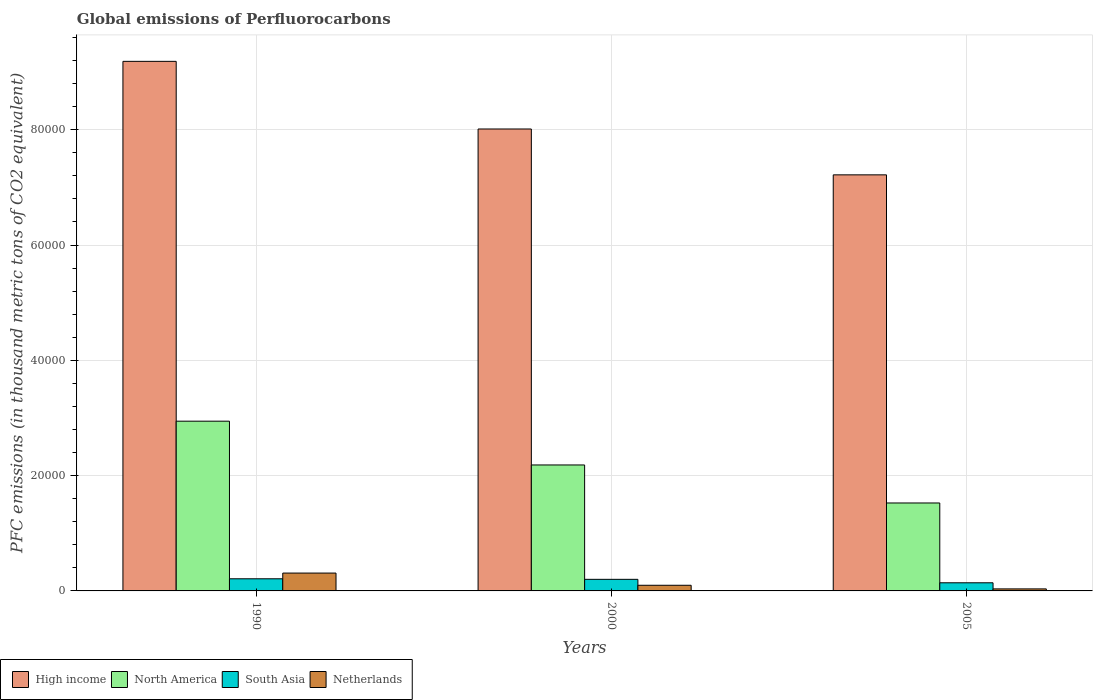How many different coloured bars are there?
Your response must be concise. 4. How many groups of bars are there?
Make the answer very short. 3. Are the number of bars per tick equal to the number of legend labels?
Keep it short and to the point. Yes. Are the number of bars on each tick of the X-axis equal?
Your answer should be compact. Yes. How many bars are there on the 3rd tick from the right?
Offer a very short reply. 4. In how many cases, is the number of bars for a given year not equal to the number of legend labels?
Keep it short and to the point. 0. What is the global emissions of Perfluorocarbons in Netherlands in 2000?
Your answer should be very brief. 979.5. Across all years, what is the maximum global emissions of Perfluorocarbons in High income?
Your answer should be compact. 9.19e+04. Across all years, what is the minimum global emissions of Perfluorocarbons in Netherlands?
Provide a short and direct response. 351.4. In which year was the global emissions of Perfluorocarbons in North America minimum?
Make the answer very short. 2005. What is the total global emissions of Perfluorocarbons in North America in the graph?
Keep it short and to the point. 6.65e+04. What is the difference between the global emissions of Perfluorocarbons in Netherlands in 2000 and that in 2005?
Keep it short and to the point. 628.1. What is the difference between the global emissions of Perfluorocarbons in Netherlands in 2000 and the global emissions of Perfluorocarbons in North America in 2005?
Provide a short and direct response. -1.43e+04. What is the average global emissions of Perfluorocarbons in South Asia per year?
Your answer should be very brief. 1841.21. In the year 2005, what is the difference between the global emissions of Perfluorocarbons in Netherlands and global emissions of Perfluorocarbons in North America?
Provide a succinct answer. -1.49e+04. What is the ratio of the global emissions of Perfluorocarbons in High income in 1990 to that in 2005?
Give a very brief answer. 1.27. Is the difference between the global emissions of Perfluorocarbons in Netherlands in 1990 and 2005 greater than the difference between the global emissions of Perfluorocarbons in North America in 1990 and 2005?
Keep it short and to the point. No. What is the difference between the highest and the second highest global emissions of Perfluorocarbons in South Asia?
Provide a short and direct response. 95.2. What is the difference between the highest and the lowest global emissions of Perfluorocarbons in High income?
Offer a terse response. 1.97e+04. Is the sum of the global emissions of Perfluorocarbons in Netherlands in 2000 and 2005 greater than the maximum global emissions of Perfluorocarbons in North America across all years?
Your response must be concise. No. Is it the case that in every year, the sum of the global emissions of Perfluorocarbons in Netherlands and global emissions of Perfluorocarbons in High income is greater than the sum of global emissions of Perfluorocarbons in North America and global emissions of Perfluorocarbons in South Asia?
Your response must be concise. Yes. What does the 4th bar from the right in 2005 represents?
Ensure brevity in your answer.  High income. Is it the case that in every year, the sum of the global emissions of Perfluorocarbons in Netherlands and global emissions of Perfluorocarbons in South Asia is greater than the global emissions of Perfluorocarbons in High income?
Your answer should be very brief. No. How many bars are there?
Provide a succinct answer. 12. Are all the bars in the graph horizontal?
Your response must be concise. No. What is the difference between two consecutive major ticks on the Y-axis?
Ensure brevity in your answer.  2.00e+04. Does the graph contain grids?
Provide a succinct answer. Yes. Where does the legend appear in the graph?
Make the answer very short. Bottom left. How many legend labels are there?
Offer a terse response. 4. What is the title of the graph?
Offer a very short reply. Global emissions of Perfluorocarbons. What is the label or title of the Y-axis?
Make the answer very short. PFC emissions (in thousand metric tons of CO2 equivalent). What is the PFC emissions (in thousand metric tons of CO2 equivalent) of High income in 1990?
Offer a very short reply. 9.19e+04. What is the PFC emissions (in thousand metric tons of CO2 equivalent) of North America in 1990?
Your response must be concise. 2.94e+04. What is the PFC emissions (in thousand metric tons of CO2 equivalent) in South Asia in 1990?
Provide a short and direct response. 2104. What is the PFC emissions (in thousand metric tons of CO2 equivalent) of Netherlands in 1990?
Your answer should be compact. 3096.2. What is the PFC emissions (in thousand metric tons of CO2 equivalent) in High income in 2000?
Your answer should be compact. 8.01e+04. What is the PFC emissions (in thousand metric tons of CO2 equivalent) in North America in 2000?
Provide a succinct answer. 2.18e+04. What is the PFC emissions (in thousand metric tons of CO2 equivalent) of South Asia in 2000?
Keep it short and to the point. 2008.8. What is the PFC emissions (in thousand metric tons of CO2 equivalent) of Netherlands in 2000?
Your answer should be very brief. 979.5. What is the PFC emissions (in thousand metric tons of CO2 equivalent) of High income in 2005?
Make the answer very short. 7.22e+04. What is the PFC emissions (in thousand metric tons of CO2 equivalent) of North America in 2005?
Your answer should be compact. 1.53e+04. What is the PFC emissions (in thousand metric tons of CO2 equivalent) of South Asia in 2005?
Offer a very short reply. 1410.84. What is the PFC emissions (in thousand metric tons of CO2 equivalent) of Netherlands in 2005?
Offer a very short reply. 351.4. Across all years, what is the maximum PFC emissions (in thousand metric tons of CO2 equivalent) of High income?
Provide a succinct answer. 9.19e+04. Across all years, what is the maximum PFC emissions (in thousand metric tons of CO2 equivalent) in North America?
Give a very brief answer. 2.94e+04. Across all years, what is the maximum PFC emissions (in thousand metric tons of CO2 equivalent) in South Asia?
Your answer should be very brief. 2104. Across all years, what is the maximum PFC emissions (in thousand metric tons of CO2 equivalent) of Netherlands?
Your answer should be very brief. 3096.2. Across all years, what is the minimum PFC emissions (in thousand metric tons of CO2 equivalent) in High income?
Make the answer very short. 7.22e+04. Across all years, what is the minimum PFC emissions (in thousand metric tons of CO2 equivalent) in North America?
Your answer should be compact. 1.53e+04. Across all years, what is the minimum PFC emissions (in thousand metric tons of CO2 equivalent) in South Asia?
Give a very brief answer. 1410.84. Across all years, what is the minimum PFC emissions (in thousand metric tons of CO2 equivalent) of Netherlands?
Offer a very short reply. 351.4. What is the total PFC emissions (in thousand metric tons of CO2 equivalent) in High income in the graph?
Your answer should be very brief. 2.44e+05. What is the total PFC emissions (in thousand metric tons of CO2 equivalent) of North America in the graph?
Provide a short and direct response. 6.65e+04. What is the total PFC emissions (in thousand metric tons of CO2 equivalent) of South Asia in the graph?
Your response must be concise. 5523.64. What is the total PFC emissions (in thousand metric tons of CO2 equivalent) of Netherlands in the graph?
Make the answer very short. 4427.1. What is the difference between the PFC emissions (in thousand metric tons of CO2 equivalent) in High income in 1990 and that in 2000?
Provide a short and direct response. 1.17e+04. What is the difference between the PFC emissions (in thousand metric tons of CO2 equivalent) in North America in 1990 and that in 2000?
Offer a terse response. 7592.7. What is the difference between the PFC emissions (in thousand metric tons of CO2 equivalent) of South Asia in 1990 and that in 2000?
Your response must be concise. 95.2. What is the difference between the PFC emissions (in thousand metric tons of CO2 equivalent) in Netherlands in 1990 and that in 2000?
Offer a very short reply. 2116.7. What is the difference between the PFC emissions (in thousand metric tons of CO2 equivalent) in High income in 1990 and that in 2005?
Provide a succinct answer. 1.97e+04. What is the difference between the PFC emissions (in thousand metric tons of CO2 equivalent) of North America in 1990 and that in 2005?
Your answer should be compact. 1.42e+04. What is the difference between the PFC emissions (in thousand metric tons of CO2 equivalent) of South Asia in 1990 and that in 2005?
Your response must be concise. 693.16. What is the difference between the PFC emissions (in thousand metric tons of CO2 equivalent) of Netherlands in 1990 and that in 2005?
Your answer should be compact. 2744.8. What is the difference between the PFC emissions (in thousand metric tons of CO2 equivalent) in High income in 2000 and that in 2005?
Make the answer very short. 7954.84. What is the difference between the PFC emissions (in thousand metric tons of CO2 equivalent) in North America in 2000 and that in 2005?
Offer a terse response. 6595.81. What is the difference between the PFC emissions (in thousand metric tons of CO2 equivalent) in South Asia in 2000 and that in 2005?
Your answer should be compact. 597.96. What is the difference between the PFC emissions (in thousand metric tons of CO2 equivalent) of Netherlands in 2000 and that in 2005?
Your answer should be very brief. 628.1. What is the difference between the PFC emissions (in thousand metric tons of CO2 equivalent) in High income in 1990 and the PFC emissions (in thousand metric tons of CO2 equivalent) in North America in 2000?
Offer a very short reply. 7.00e+04. What is the difference between the PFC emissions (in thousand metric tons of CO2 equivalent) in High income in 1990 and the PFC emissions (in thousand metric tons of CO2 equivalent) in South Asia in 2000?
Offer a terse response. 8.98e+04. What is the difference between the PFC emissions (in thousand metric tons of CO2 equivalent) in High income in 1990 and the PFC emissions (in thousand metric tons of CO2 equivalent) in Netherlands in 2000?
Keep it short and to the point. 9.09e+04. What is the difference between the PFC emissions (in thousand metric tons of CO2 equivalent) in North America in 1990 and the PFC emissions (in thousand metric tons of CO2 equivalent) in South Asia in 2000?
Offer a very short reply. 2.74e+04. What is the difference between the PFC emissions (in thousand metric tons of CO2 equivalent) in North America in 1990 and the PFC emissions (in thousand metric tons of CO2 equivalent) in Netherlands in 2000?
Keep it short and to the point. 2.85e+04. What is the difference between the PFC emissions (in thousand metric tons of CO2 equivalent) of South Asia in 1990 and the PFC emissions (in thousand metric tons of CO2 equivalent) of Netherlands in 2000?
Provide a short and direct response. 1124.5. What is the difference between the PFC emissions (in thousand metric tons of CO2 equivalent) in High income in 1990 and the PFC emissions (in thousand metric tons of CO2 equivalent) in North America in 2005?
Your answer should be very brief. 7.66e+04. What is the difference between the PFC emissions (in thousand metric tons of CO2 equivalent) of High income in 1990 and the PFC emissions (in thousand metric tons of CO2 equivalent) of South Asia in 2005?
Your answer should be very brief. 9.04e+04. What is the difference between the PFC emissions (in thousand metric tons of CO2 equivalent) in High income in 1990 and the PFC emissions (in thousand metric tons of CO2 equivalent) in Netherlands in 2005?
Give a very brief answer. 9.15e+04. What is the difference between the PFC emissions (in thousand metric tons of CO2 equivalent) in North America in 1990 and the PFC emissions (in thousand metric tons of CO2 equivalent) in South Asia in 2005?
Provide a short and direct response. 2.80e+04. What is the difference between the PFC emissions (in thousand metric tons of CO2 equivalent) in North America in 1990 and the PFC emissions (in thousand metric tons of CO2 equivalent) in Netherlands in 2005?
Offer a terse response. 2.91e+04. What is the difference between the PFC emissions (in thousand metric tons of CO2 equivalent) of South Asia in 1990 and the PFC emissions (in thousand metric tons of CO2 equivalent) of Netherlands in 2005?
Offer a terse response. 1752.6. What is the difference between the PFC emissions (in thousand metric tons of CO2 equivalent) in High income in 2000 and the PFC emissions (in thousand metric tons of CO2 equivalent) in North America in 2005?
Offer a very short reply. 6.49e+04. What is the difference between the PFC emissions (in thousand metric tons of CO2 equivalent) in High income in 2000 and the PFC emissions (in thousand metric tons of CO2 equivalent) in South Asia in 2005?
Your response must be concise. 7.87e+04. What is the difference between the PFC emissions (in thousand metric tons of CO2 equivalent) in High income in 2000 and the PFC emissions (in thousand metric tons of CO2 equivalent) in Netherlands in 2005?
Offer a terse response. 7.98e+04. What is the difference between the PFC emissions (in thousand metric tons of CO2 equivalent) of North America in 2000 and the PFC emissions (in thousand metric tons of CO2 equivalent) of South Asia in 2005?
Your answer should be compact. 2.04e+04. What is the difference between the PFC emissions (in thousand metric tons of CO2 equivalent) of North America in 2000 and the PFC emissions (in thousand metric tons of CO2 equivalent) of Netherlands in 2005?
Your response must be concise. 2.15e+04. What is the difference between the PFC emissions (in thousand metric tons of CO2 equivalent) of South Asia in 2000 and the PFC emissions (in thousand metric tons of CO2 equivalent) of Netherlands in 2005?
Your answer should be very brief. 1657.4. What is the average PFC emissions (in thousand metric tons of CO2 equivalent) in High income per year?
Provide a succinct answer. 8.14e+04. What is the average PFC emissions (in thousand metric tons of CO2 equivalent) of North America per year?
Ensure brevity in your answer.  2.22e+04. What is the average PFC emissions (in thousand metric tons of CO2 equivalent) of South Asia per year?
Provide a short and direct response. 1841.21. What is the average PFC emissions (in thousand metric tons of CO2 equivalent) in Netherlands per year?
Offer a terse response. 1475.7. In the year 1990, what is the difference between the PFC emissions (in thousand metric tons of CO2 equivalent) of High income and PFC emissions (in thousand metric tons of CO2 equivalent) of North America?
Provide a succinct answer. 6.24e+04. In the year 1990, what is the difference between the PFC emissions (in thousand metric tons of CO2 equivalent) of High income and PFC emissions (in thousand metric tons of CO2 equivalent) of South Asia?
Make the answer very short. 8.98e+04. In the year 1990, what is the difference between the PFC emissions (in thousand metric tons of CO2 equivalent) of High income and PFC emissions (in thousand metric tons of CO2 equivalent) of Netherlands?
Make the answer very short. 8.88e+04. In the year 1990, what is the difference between the PFC emissions (in thousand metric tons of CO2 equivalent) of North America and PFC emissions (in thousand metric tons of CO2 equivalent) of South Asia?
Ensure brevity in your answer.  2.73e+04. In the year 1990, what is the difference between the PFC emissions (in thousand metric tons of CO2 equivalent) of North America and PFC emissions (in thousand metric tons of CO2 equivalent) of Netherlands?
Offer a very short reply. 2.63e+04. In the year 1990, what is the difference between the PFC emissions (in thousand metric tons of CO2 equivalent) of South Asia and PFC emissions (in thousand metric tons of CO2 equivalent) of Netherlands?
Give a very brief answer. -992.2. In the year 2000, what is the difference between the PFC emissions (in thousand metric tons of CO2 equivalent) in High income and PFC emissions (in thousand metric tons of CO2 equivalent) in North America?
Provide a succinct answer. 5.83e+04. In the year 2000, what is the difference between the PFC emissions (in thousand metric tons of CO2 equivalent) of High income and PFC emissions (in thousand metric tons of CO2 equivalent) of South Asia?
Give a very brief answer. 7.81e+04. In the year 2000, what is the difference between the PFC emissions (in thousand metric tons of CO2 equivalent) of High income and PFC emissions (in thousand metric tons of CO2 equivalent) of Netherlands?
Ensure brevity in your answer.  7.91e+04. In the year 2000, what is the difference between the PFC emissions (in thousand metric tons of CO2 equivalent) in North America and PFC emissions (in thousand metric tons of CO2 equivalent) in South Asia?
Provide a succinct answer. 1.98e+04. In the year 2000, what is the difference between the PFC emissions (in thousand metric tons of CO2 equivalent) of North America and PFC emissions (in thousand metric tons of CO2 equivalent) of Netherlands?
Make the answer very short. 2.09e+04. In the year 2000, what is the difference between the PFC emissions (in thousand metric tons of CO2 equivalent) in South Asia and PFC emissions (in thousand metric tons of CO2 equivalent) in Netherlands?
Your response must be concise. 1029.3. In the year 2005, what is the difference between the PFC emissions (in thousand metric tons of CO2 equivalent) in High income and PFC emissions (in thousand metric tons of CO2 equivalent) in North America?
Your answer should be compact. 5.69e+04. In the year 2005, what is the difference between the PFC emissions (in thousand metric tons of CO2 equivalent) in High income and PFC emissions (in thousand metric tons of CO2 equivalent) in South Asia?
Keep it short and to the point. 7.08e+04. In the year 2005, what is the difference between the PFC emissions (in thousand metric tons of CO2 equivalent) of High income and PFC emissions (in thousand metric tons of CO2 equivalent) of Netherlands?
Ensure brevity in your answer.  7.18e+04. In the year 2005, what is the difference between the PFC emissions (in thousand metric tons of CO2 equivalent) of North America and PFC emissions (in thousand metric tons of CO2 equivalent) of South Asia?
Ensure brevity in your answer.  1.38e+04. In the year 2005, what is the difference between the PFC emissions (in thousand metric tons of CO2 equivalent) in North America and PFC emissions (in thousand metric tons of CO2 equivalent) in Netherlands?
Offer a very short reply. 1.49e+04. In the year 2005, what is the difference between the PFC emissions (in thousand metric tons of CO2 equivalent) of South Asia and PFC emissions (in thousand metric tons of CO2 equivalent) of Netherlands?
Your answer should be very brief. 1059.44. What is the ratio of the PFC emissions (in thousand metric tons of CO2 equivalent) in High income in 1990 to that in 2000?
Provide a short and direct response. 1.15. What is the ratio of the PFC emissions (in thousand metric tons of CO2 equivalent) in North America in 1990 to that in 2000?
Make the answer very short. 1.35. What is the ratio of the PFC emissions (in thousand metric tons of CO2 equivalent) of South Asia in 1990 to that in 2000?
Provide a succinct answer. 1.05. What is the ratio of the PFC emissions (in thousand metric tons of CO2 equivalent) in Netherlands in 1990 to that in 2000?
Keep it short and to the point. 3.16. What is the ratio of the PFC emissions (in thousand metric tons of CO2 equivalent) of High income in 1990 to that in 2005?
Offer a terse response. 1.27. What is the ratio of the PFC emissions (in thousand metric tons of CO2 equivalent) of North America in 1990 to that in 2005?
Your response must be concise. 1.93. What is the ratio of the PFC emissions (in thousand metric tons of CO2 equivalent) of South Asia in 1990 to that in 2005?
Offer a terse response. 1.49. What is the ratio of the PFC emissions (in thousand metric tons of CO2 equivalent) of Netherlands in 1990 to that in 2005?
Your answer should be compact. 8.81. What is the ratio of the PFC emissions (in thousand metric tons of CO2 equivalent) in High income in 2000 to that in 2005?
Give a very brief answer. 1.11. What is the ratio of the PFC emissions (in thousand metric tons of CO2 equivalent) of North America in 2000 to that in 2005?
Your answer should be compact. 1.43. What is the ratio of the PFC emissions (in thousand metric tons of CO2 equivalent) in South Asia in 2000 to that in 2005?
Provide a succinct answer. 1.42. What is the ratio of the PFC emissions (in thousand metric tons of CO2 equivalent) in Netherlands in 2000 to that in 2005?
Make the answer very short. 2.79. What is the difference between the highest and the second highest PFC emissions (in thousand metric tons of CO2 equivalent) in High income?
Offer a very short reply. 1.17e+04. What is the difference between the highest and the second highest PFC emissions (in thousand metric tons of CO2 equivalent) of North America?
Provide a succinct answer. 7592.7. What is the difference between the highest and the second highest PFC emissions (in thousand metric tons of CO2 equivalent) of South Asia?
Ensure brevity in your answer.  95.2. What is the difference between the highest and the second highest PFC emissions (in thousand metric tons of CO2 equivalent) of Netherlands?
Offer a very short reply. 2116.7. What is the difference between the highest and the lowest PFC emissions (in thousand metric tons of CO2 equivalent) in High income?
Provide a short and direct response. 1.97e+04. What is the difference between the highest and the lowest PFC emissions (in thousand metric tons of CO2 equivalent) of North America?
Provide a succinct answer. 1.42e+04. What is the difference between the highest and the lowest PFC emissions (in thousand metric tons of CO2 equivalent) in South Asia?
Your answer should be compact. 693.16. What is the difference between the highest and the lowest PFC emissions (in thousand metric tons of CO2 equivalent) in Netherlands?
Offer a very short reply. 2744.8. 